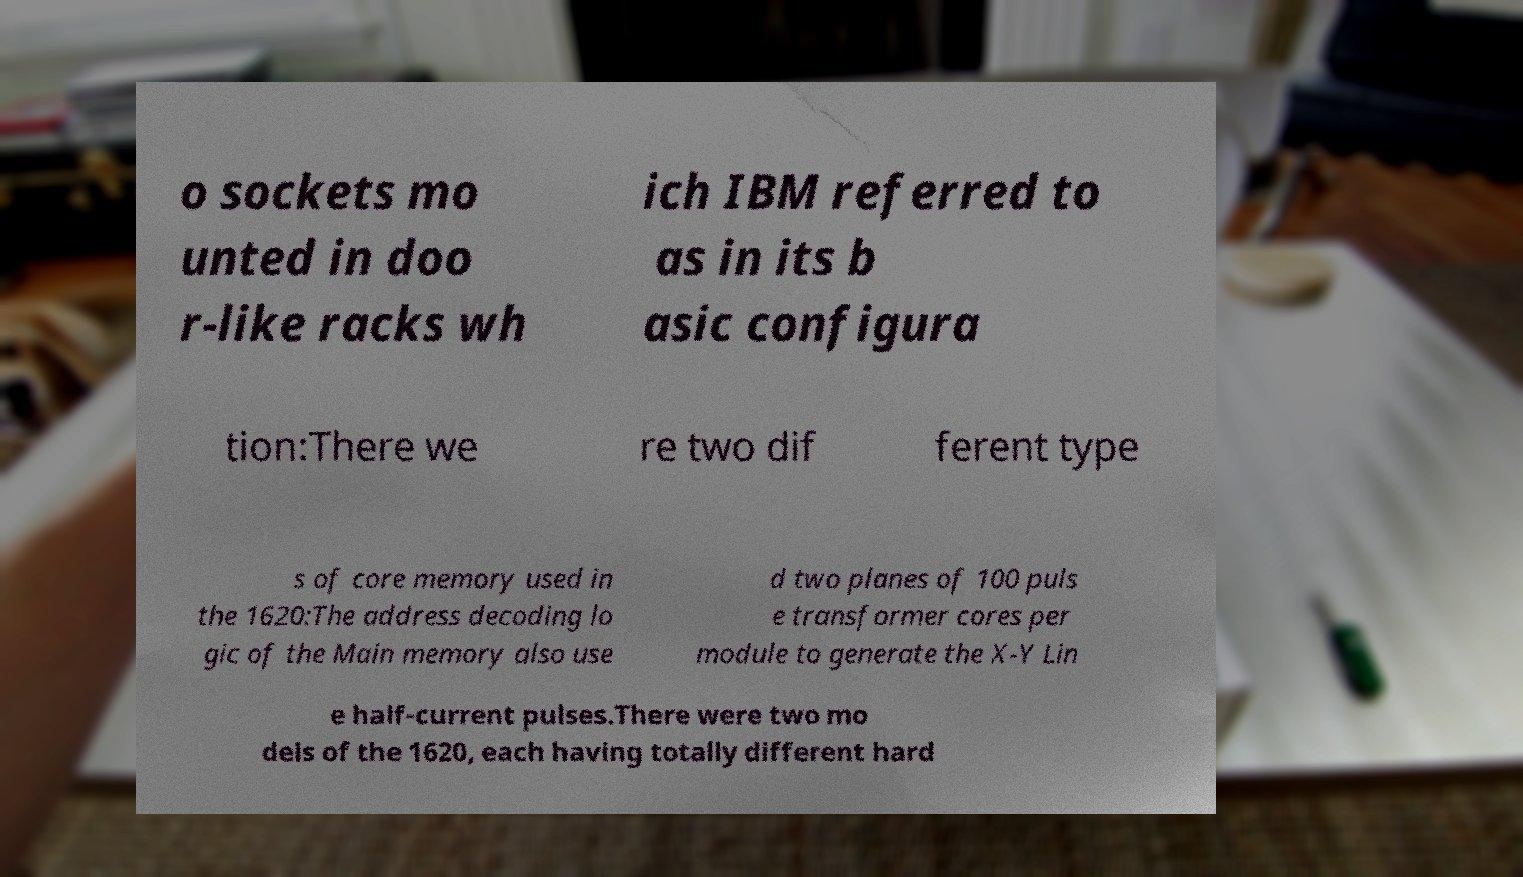Could you extract and type out the text from this image? o sockets mo unted in doo r-like racks wh ich IBM referred to as in its b asic configura tion:There we re two dif ferent type s of core memory used in the 1620:The address decoding lo gic of the Main memory also use d two planes of 100 puls e transformer cores per module to generate the X-Y Lin e half-current pulses.There were two mo dels of the 1620, each having totally different hard 